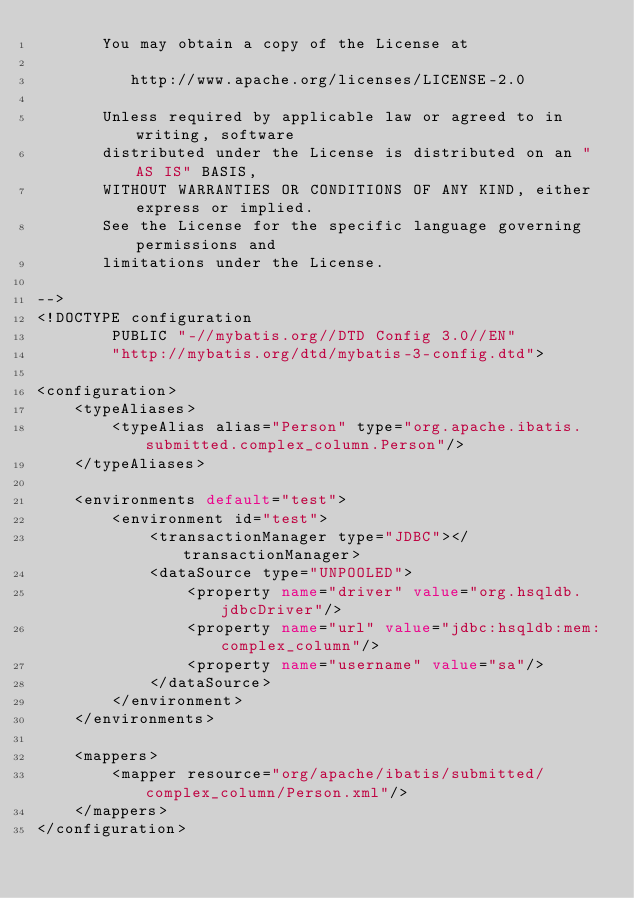<code> <loc_0><loc_0><loc_500><loc_500><_XML_>       You may obtain a copy of the License at

          http://www.apache.org/licenses/LICENSE-2.0

       Unless required by applicable law or agreed to in writing, software
       distributed under the License is distributed on an "AS IS" BASIS,
       WITHOUT WARRANTIES OR CONDITIONS OF ANY KIND, either express or implied.
       See the License for the specific language governing permissions and
       limitations under the License.

-->
<!DOCTYPE configuration
        PUBLIC "-//mybatis.org//DTD Config 3.0//EN"
        "http://mybatis.org/dtd/mybatis-3-config.dtd">

<configuration>
    <typeAliases>
        <typeAlias alias="Person" type="org.apache.ibatis.submitted.complex_column.Person"/>
    </typeAliases>

    <environments default="test">
        <environment id="test">
            <transactionManager type="JDBC"></transactionManager>
            <dataSource type="UNPOOLED">
                <property name="driver" value="org.hsqldb.jdbcDriver"/>
                <property name="url" value="jdbc:hsqldb:mem:complex_column"/>
                <property name="username" value="sa"/>
            </dataSource>
        </environment>
    </environments>

    <mappers>
        <mapper resource="org/apache/ibatis/submitted/complex_column/Person.xml"/>
    </mappers>
</configuration>
</code> 